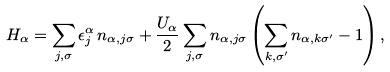<formula> <loc_0><loc_0><loc_500><loc_500>H _ { \alpha } = \sum _ { j , \sigma } \epsilon _ { j } ^ { \alpha } \, n _ { \alpha , j \sigma } + \frac { U _ { \alpha } } { 2 } \sum _ { j , \sigma } n _ { \alpha , j \sigma } \left ( \sum _ { k , \sigma ^ { \prime } } n _ { \alpha , k \sigma ^ { \prime } } - 1 \right ) ,</formula> 